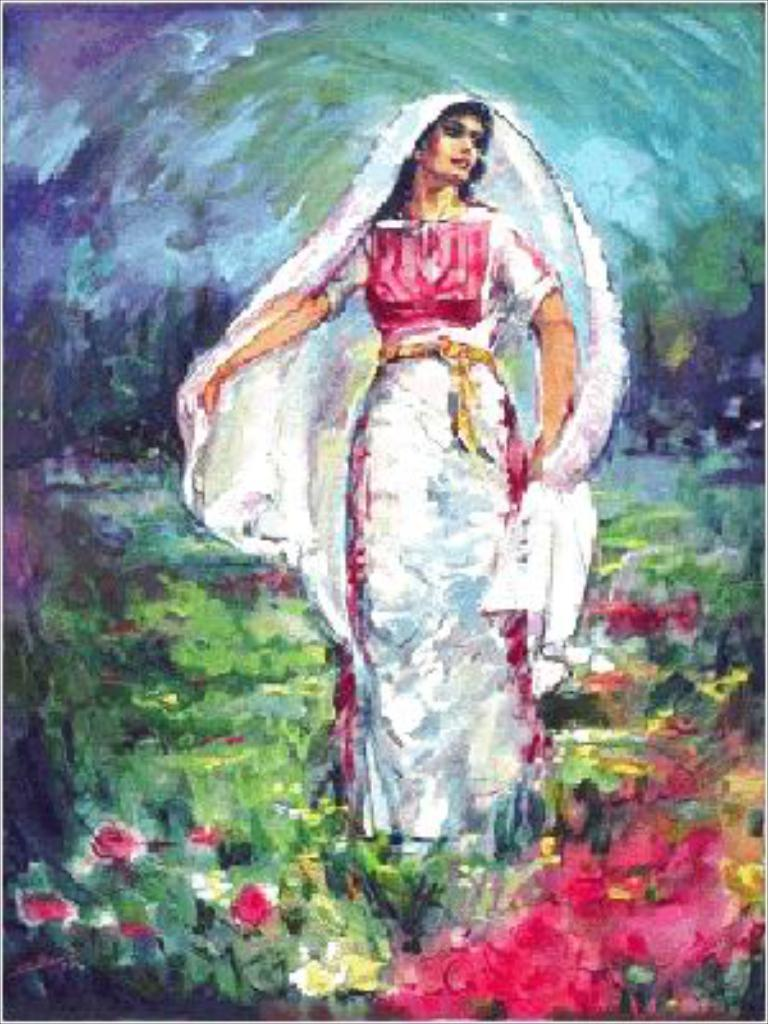What is the main subject of the image? There is a portrait in the image. How does the portrait kick a soccer ball in the image? The portrait does not kick a soccer ball in the image, as it is a static representation of a person or object. 